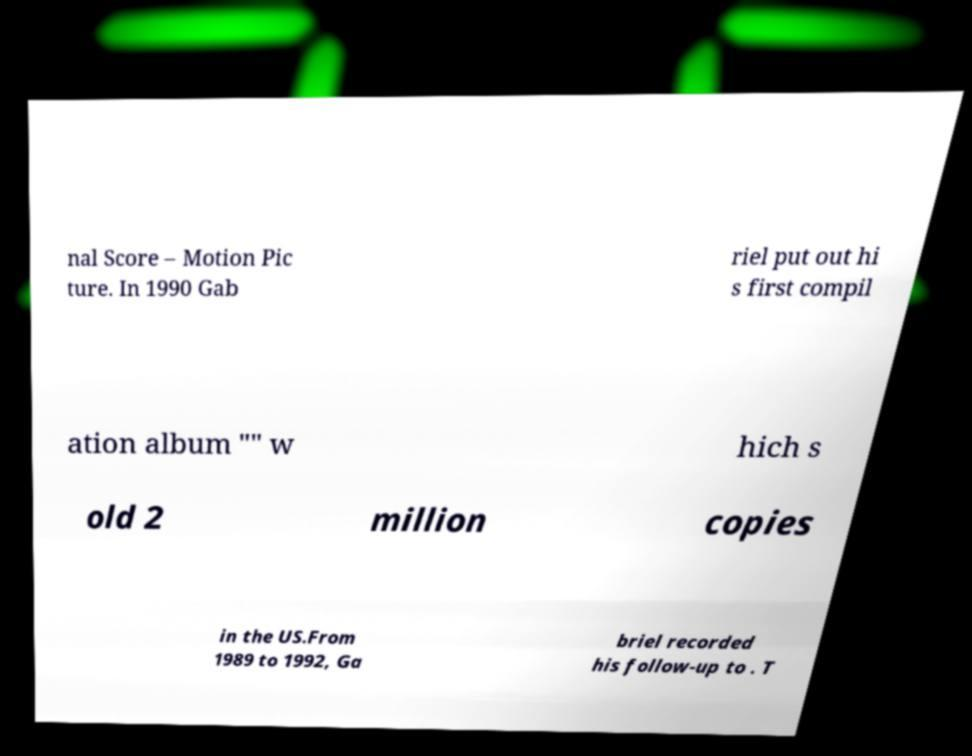Please identify and transcribe the text found in this image. nal Score – Motion Pic ture. In 1990 Gab riel put out hi s first compil ation album "" w hich s old 2 million copies in the US.From 1989 to 1992, Ga briel recorded his follow-up to . T 